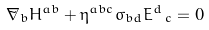Convert formula to latex. <formula><loc_0><loc_0><loc_500><loc_500>\tilde { \nabla } _ { b } H ^ { a b } + \eta ^ { a b c } \sigma _ { b d } E ^ { d } \, _ { c } = 0</formula> 